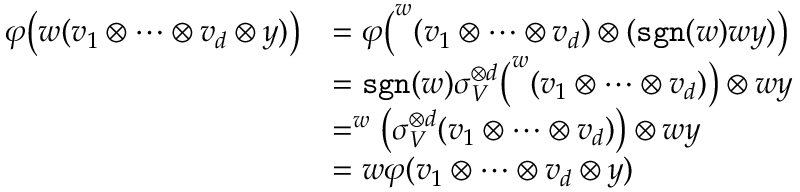Convert formula to latex. <formula><loc_0><loc_0><loc_500><loc_500>\begin{array} { r l } { { \varphi } \left ( w ( v _ { 1 } \otimes \dots \otimes v _ { d } \otimes y ) \right ) } & { = { \varphi } \left ( ^ { w } ( v _ { 1 } \otimes \dots \otimes v _ { d } ) \otimes ( s g n ( w ) w y ) \right ) } \\ & { = s g n ( w ) \sigma _ { V } ^ { \otimes d } \left ( ^ { w } ( v _ { 1 } \otimes \dots \otimes v _ { d } ) \right ) \otimes w y } \\ & { = ^ { w } \left ( \sigma _ { V } ^ { \otimes d } ( v _ { 1 } \otimes \dots \otimes v _ { d } ) \right ) \otimes w y } \\ & { = w { \varphi } ( v _ { 1 } \otimes \dots \otimes v _ { d } \otimes y ) } \end{array}</formula> 